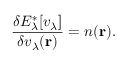Convert formula to latex. <formula><loc_0><loc_0><loc_500><loc_500>\frac { \delta E _ { \lambda } ^ { \ast } [ v _ { \lambda } ] } { \delta v _ { \lambda } ( r ) } = n ( r ) .</formula> 